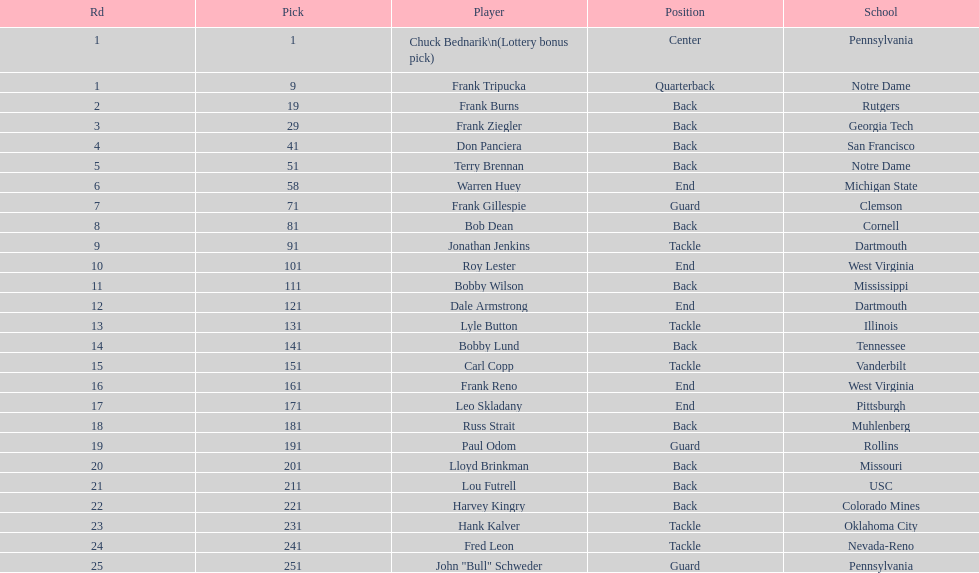Who was picked after frank burns? Frank Ziegler. 